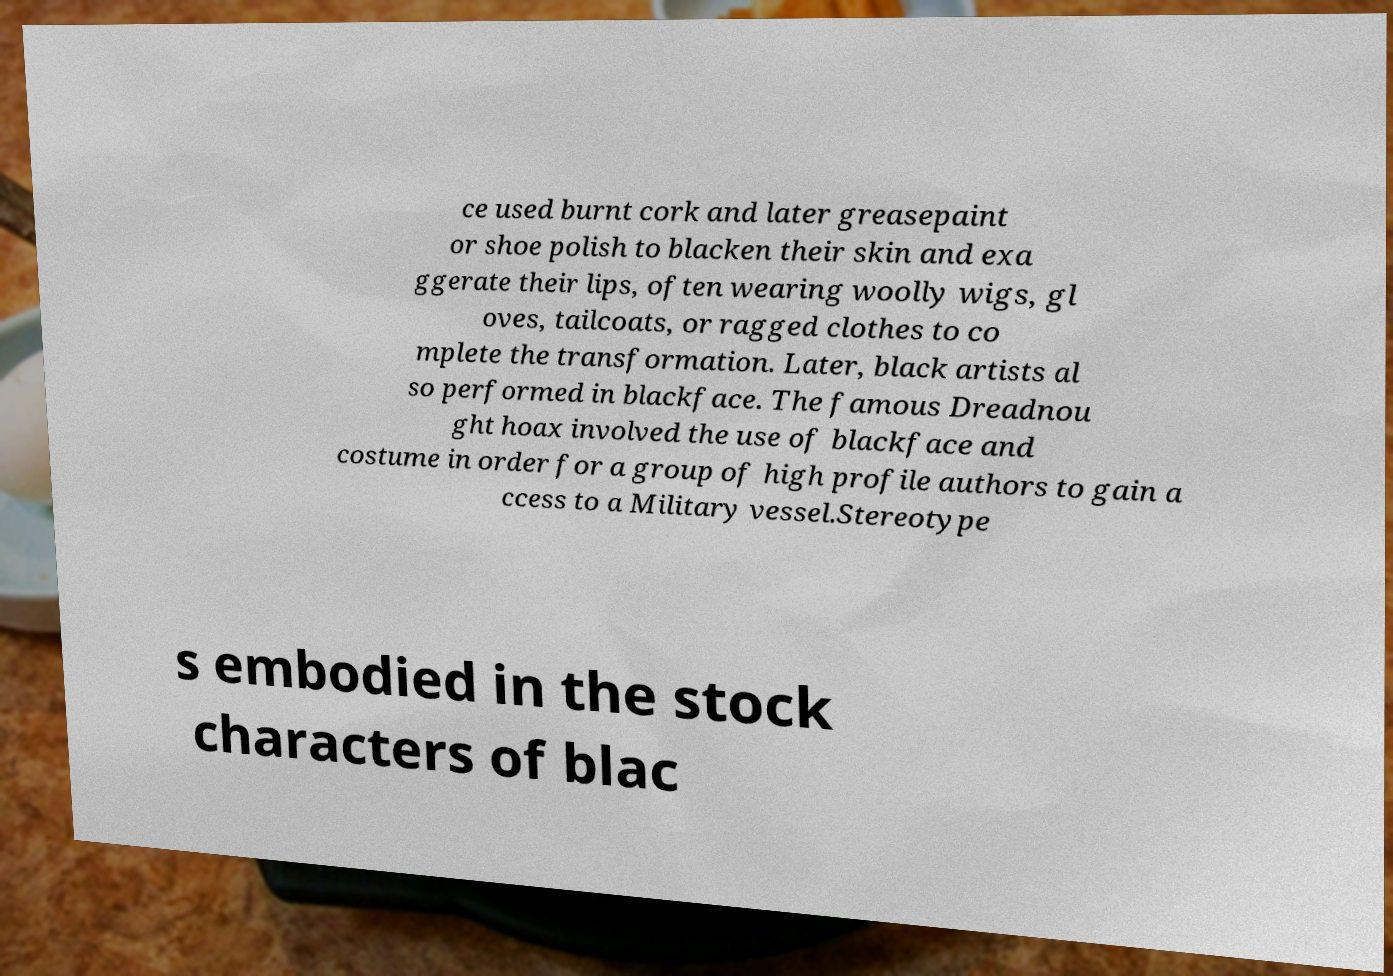There's text embedded in this image that I need extracted. Can you transcribe it verbatim? ce used burnt cork and later greasepaint or shoe polish to blacken their skin and exa ggerate their lips, often wearing woolly wigs, gl oves, tailcoats, or ragged clothes to co mplete the transformation. Later, black artists al so performed in blackface. The famous Dreadnou ght hoax involved the use of blackface and costume in order for a group of high profile authors to gain a ccess to a Military vessel.Stereotype s embodied in the stock characters of blac 